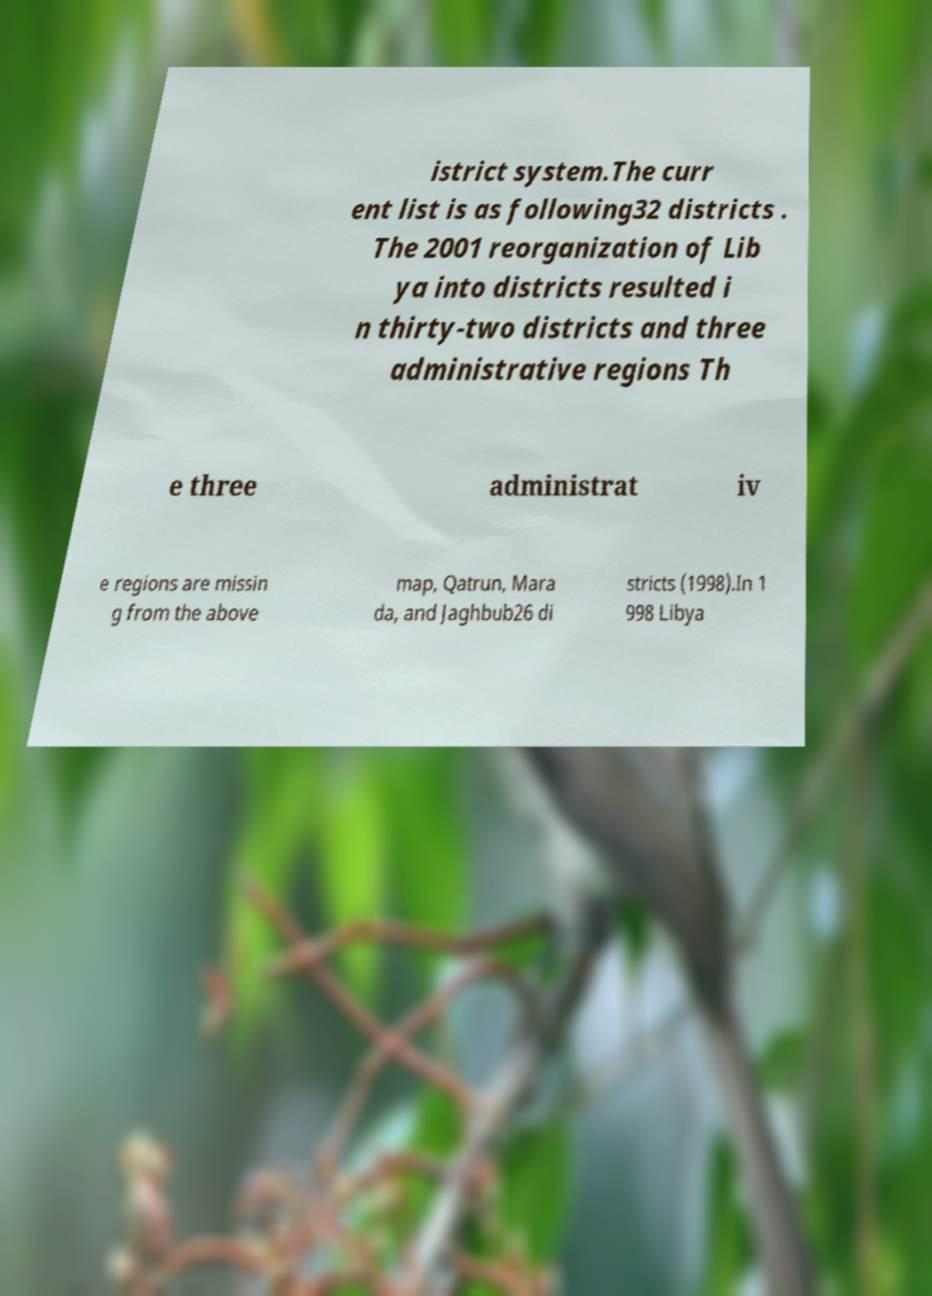There's text embedded in this image that I need extracted. Can you transcribe it verbatim? istrict system.The curr ent list is as following32 districts . The 2001 reorganization of Lib ya into districts resulted i n thirty-two districts and three administrative regions Th e three administrat iv e regions are missin g from the above map, Qatrun, Mara da, and Jaghbub26 di stricts (1998).In 1 998 Libya 